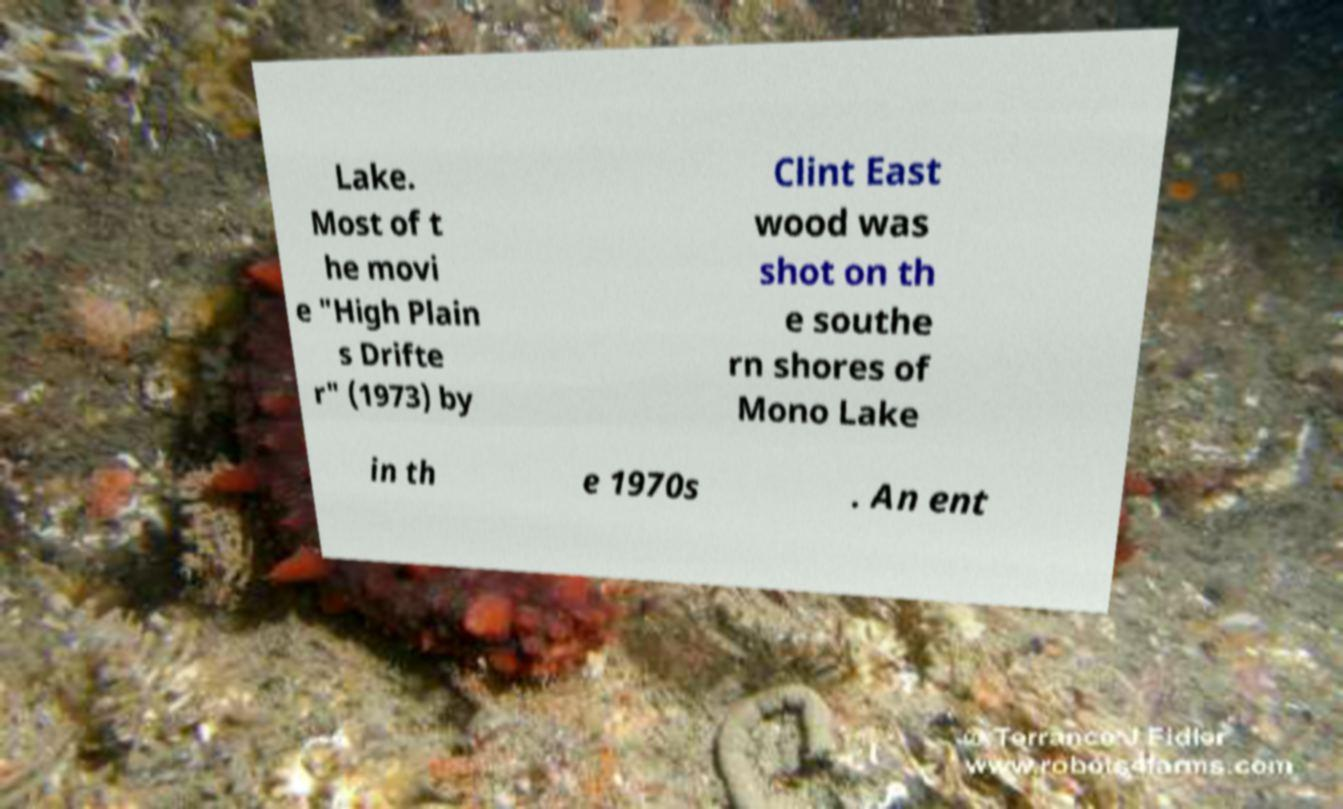Could you extract and type out the text from this image? Lake. Most of t he movi e "High Plain s Drifte r" (1973) by Clint East wood was shot on th e southe rn shores of Mono Lake in th e 1970s . An ent 